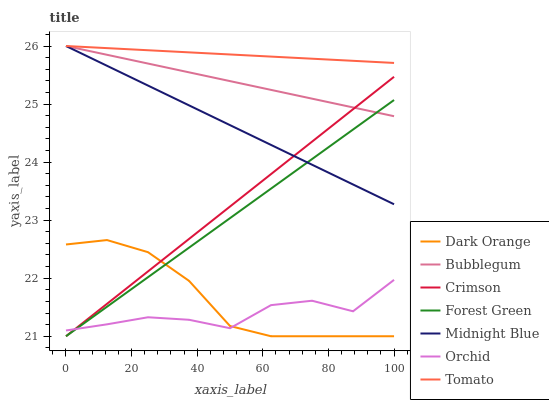Does Orchid have the minimum area under the curve?
Answer yes or no. Yes. Does Tomato have the maximum area under the curve?
Answer yes or no. Yes. Does Dark Orange have the minimum area under the curve?
Answer yes or no. No. Does Dark Orange have the maximum area under the curve?
Answer yes or no. No. Is Tomato the smoothest?
Answer yes or no. Yes. Is Orchid the roughest?
Answer yes or no. Yes. Is Dark Orange the smoothest?
Answer yes or no. No. Is Dark Orange the roughest?
Answer yes or no. No. Does Midnight Blue have the lowest value?
Answer yes or no. No. Does Bubblegum have the highest value?
Answer yes or no. Yes. Does Dark Orange have the highest value?
Answer yes or no. No. Is Orchid less than Midnight Blue?
Answer yes or no. Yes. Is Bubblegum greater than Dark Orange?
Answer yes or no. Yes. Does Midnight Blue intersect Bubblegum?
Answer yes or no. Yes. Is Midnight Blue less than Bubblegum?
Answer yes or no. No. Is Midnight Blue greater than Bubblegum?
Answer yes or no. No. Does Orchid intersect Midnight Blue?
Answer yes or no. No. 